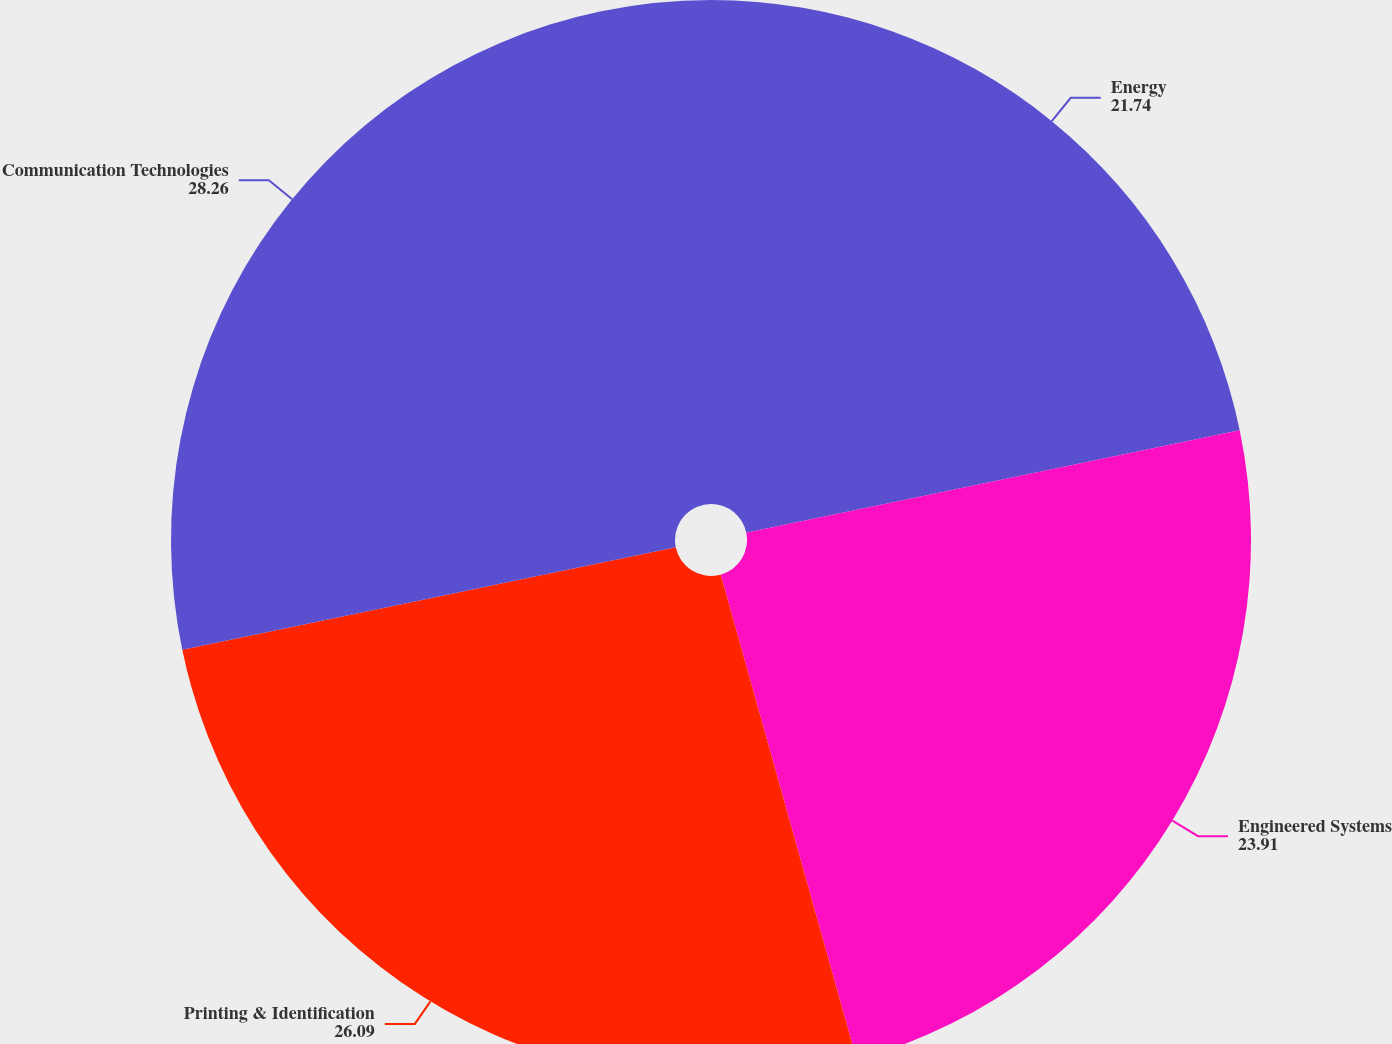Convert chart to OTSL. <chart><loc_0><loc_0><loc_500><loc_500><pie_chart><fcel>Energy<fcel>Engineered Systems<fcel>Printing & Identification<fcel>Communication Technologies<nl><fcel>21.74%<fcel>23.91%<fcel>26.09%<fcel>28.26%<nl></chart> 